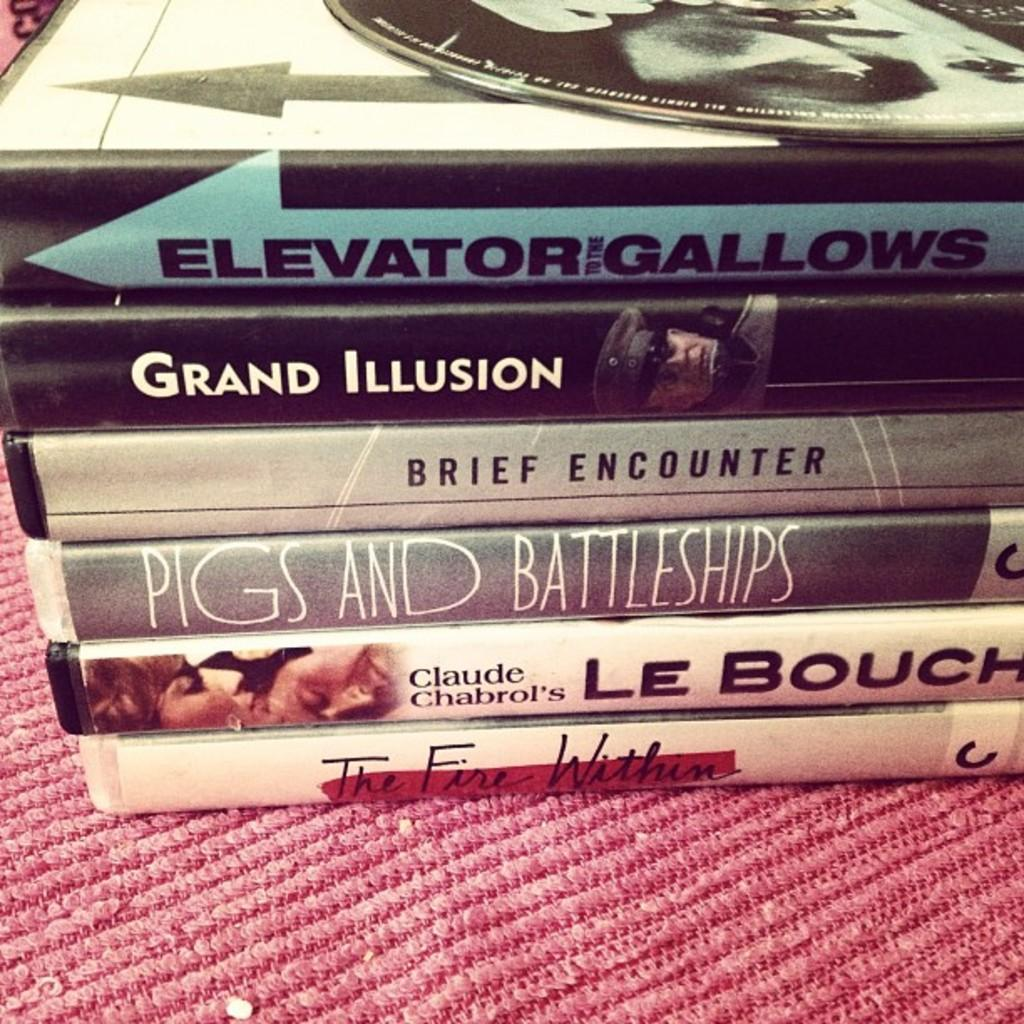<image>
Share a concise interpretation of the image provided. Elevator Gallows is on the top of a stack of books. 